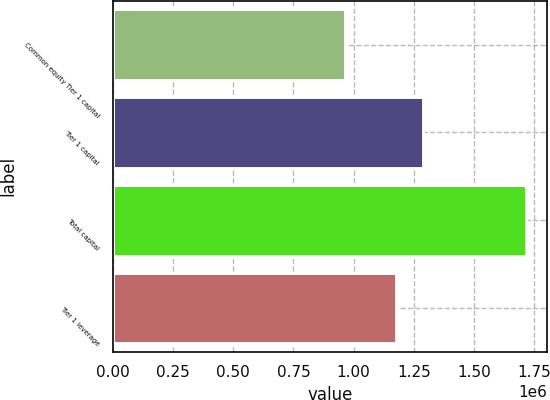Convert chart. <chart><loc_0><loc_0><loc_500><loc_500><bar_chart><fcel>Common equity Tier 1 capital<fcel>Tier 1 capital<fcel>Total capital<fcel>Tier 1 leverage<nl><fcel>966341<fcel>1.28845e+06<fcel>1.71794e+06<fcel>1.17784e+06<nl></chart> 